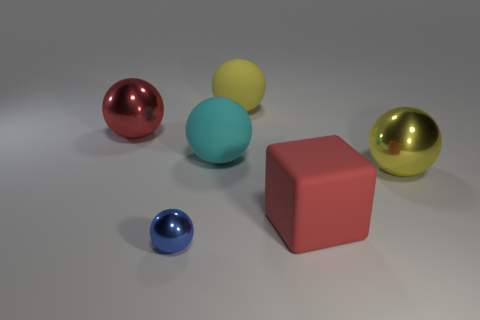Which object stands out the most and why? The red cube stands out the most among the objects due to its distinct shape and color. While the spheres share a common shape with differing sizes and colors, the cube's form is a sharp contrast, drawing the eye with its solid angles and uniform color. 